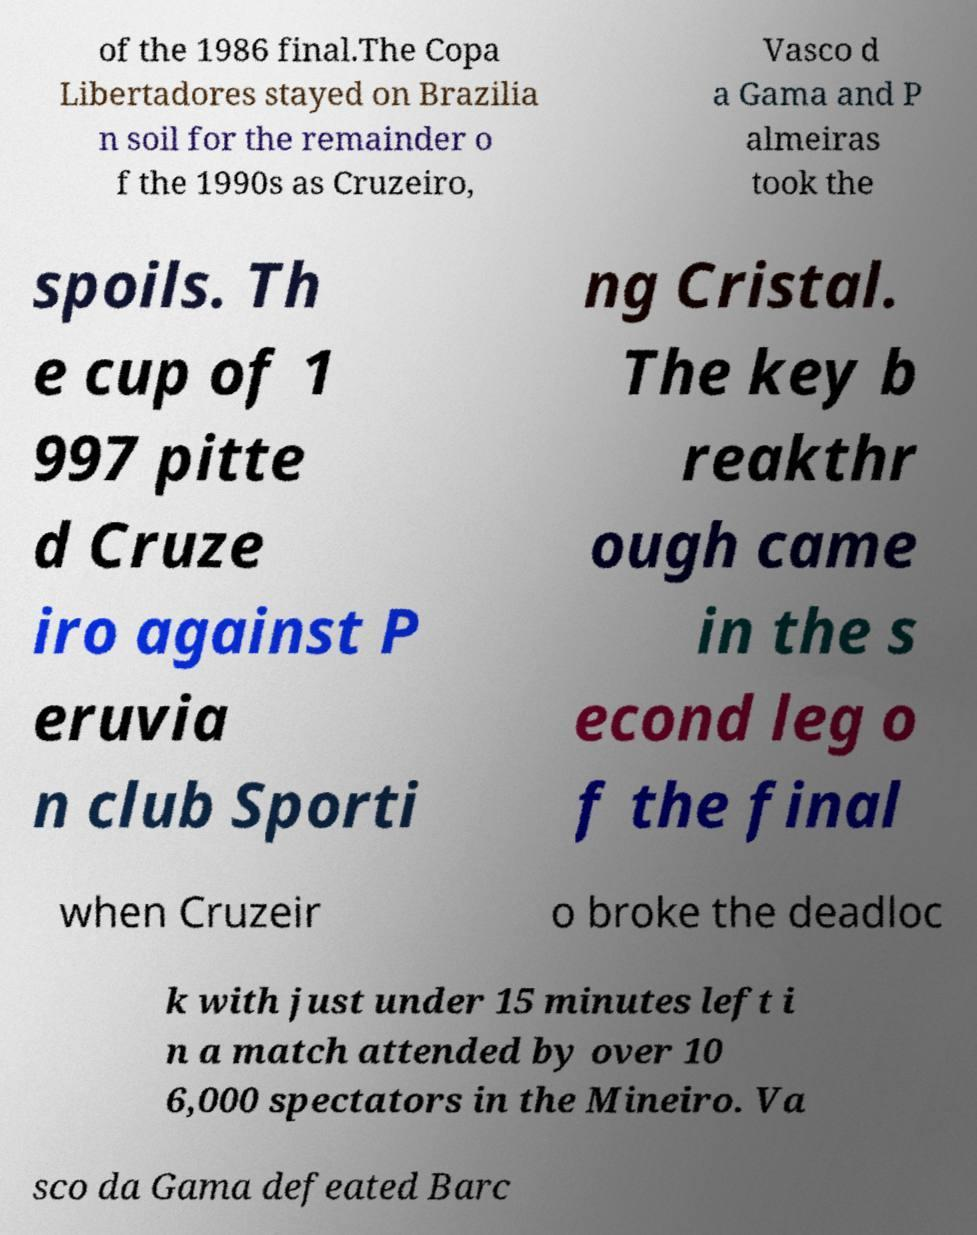There's text embedded in this image that I need extracted. Can you transcribe it verbatim? of the 1986 final.The Copa Libertadores stayed on Brazilia n soil for the remainder o f the 1990s as Cruzeiro, Vasco d a Gama and P almeiras took the spoils. Th e cup of 1 997 pitte d Cruze iro against P eruvia n club Sporti ng Cristal. The key b reakthr ough came in the s econd leg o f the final when Cruzeir o broke the deadloc k with just under 15 minutes left i n a match attended by over 10 6,000 spectators in the Mineiro. Va sco da Gama defeated Barc 